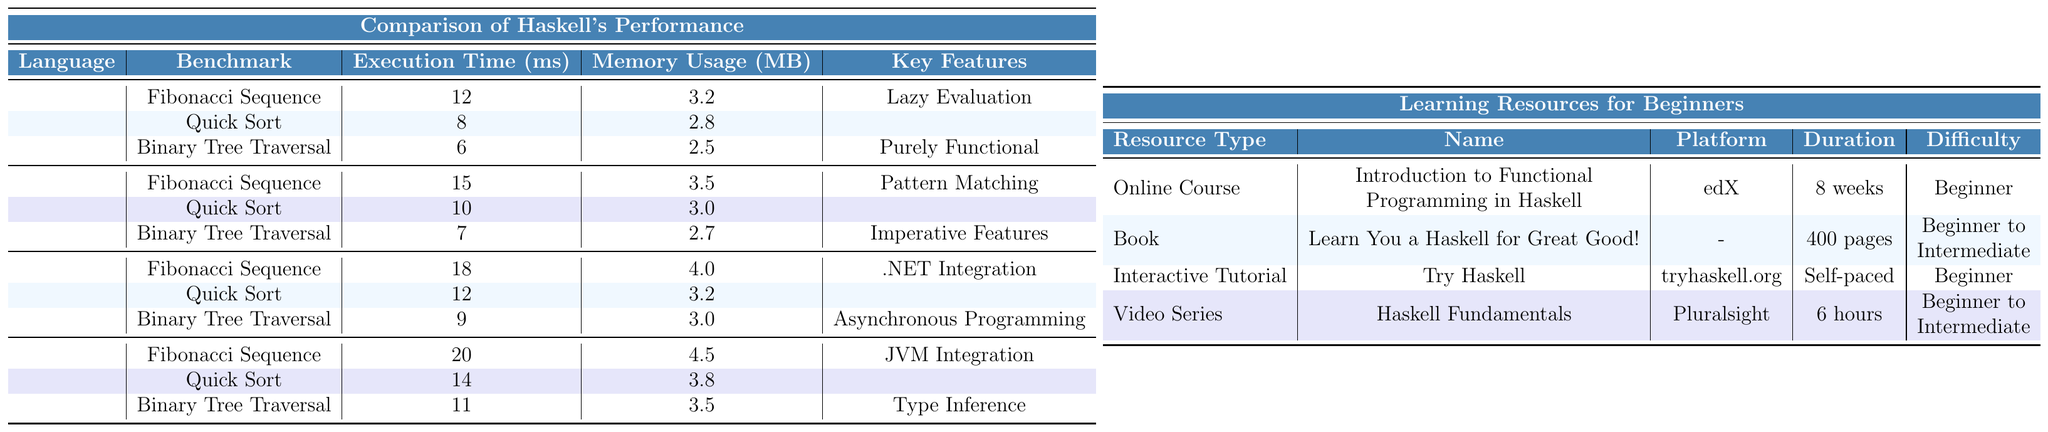What is the execution time of the Fibonacci Sequence in Haskell? The execution time for the Fibonacci Sequence in Haskell is indicated in the table under the "Execution Time (ms)" column for Haskell. It shows a value of 12 ms.
Answer: 12 ms Which language has the highest memory usage for Binary Tree Traversal? The memory usage for Binary Tree Traversal is listed as follows: Haskell - 2.5 MB, OCaml - 2.7 MB, F# - 3.0 MB, Scala - 3.5 MB. The highest value is 3.5 MB for Scala.
Answer: Scala What are the key features of OCaml? The key features of OCaml are listed in the table and include Pattern Matching, Modules, and Imperative Features.
Answer: Pattern Matching, Modules, Imperative Features How much faster is the Quick Sort execution time in Haskell compared to F#? The execution time for Quick Sort is 8 ms in Haskell and 12 ms in F#. To find the difference, subtract: 12 - 8 = 4 ms. Haskell is 4 ms faster.
Answer: 4 ms What is the average execution time of the Fibonacci Sequence across all languages? The execution times for Fibonacci Sequence are: Haskell - 12 ms, OCaml - 15 ms, F# - 18 ms, Scala - 20 ms. To find the average, sum them up (12 + 15 + 18 + 20 = 65) and divide by 4 (65 / 4 = 16.25).
Answer: 16.25 ms Is F# more memory-intensive than Haskell for Quick Sort? The memory usage for Quick Sort in Haskell is 2.8 MB, whereas in F# it is 3.2 MB. Since 3.2 MB is greater than 2.8 MB, it is true that F# is more memory-intensive.
Answer: Yes Which programming language shows a decrease in execution time for Binary Tree Traversal from Quick Sort? The execution time for Quick Sort is as follows: Haskell - 8 ms, F# - 12 ms, Scala - 14 ms. The Binary Tree Traversal times are Haskell - 6 ms, F# - 9 ms, Scala - 11 ms. Comparing these, only Haskell shows a decrease (8 to 6 ms).
Answer: Haskell Which language has the lowest execution time for Binary Tree Traversal? The execution times for Binary Tree Traversal are: Haskell - 6 ms, OCaml - 7 ms, F# - 9 ms, Scala - 11 ms. Haskell has the lowest execution time at 6 ms.
Answer: Haskell 